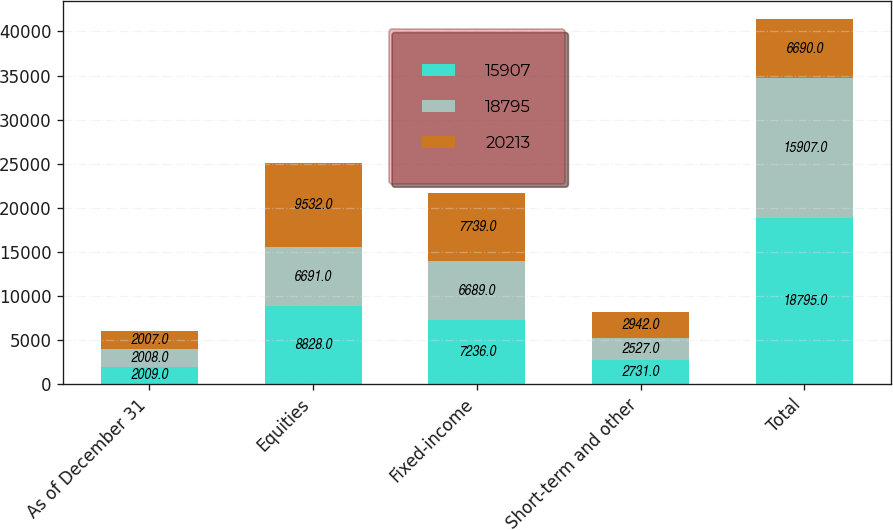Convert chart. <chart><loc_0><loc_0><loc_500><loc_500><stacked_bar_chart><ecel><fcel>As of December 31<fcel>Equities<fcel>Fixed-income<fcel>Short-term and other<fcel>Total<nl><fcel>15907<fcel>2009<fcel>8828<fcel>7236<fcel>2731<fcel>18795<nl><fcel>18795<fcel>2008<fcel>6691<fcel>6689<fcel>2527<fcel>15907<nl><fcel>20213<fcel>2007<fcel>9532<fcel>7739<fcel>2942<fcel>6690<nl></chart> 